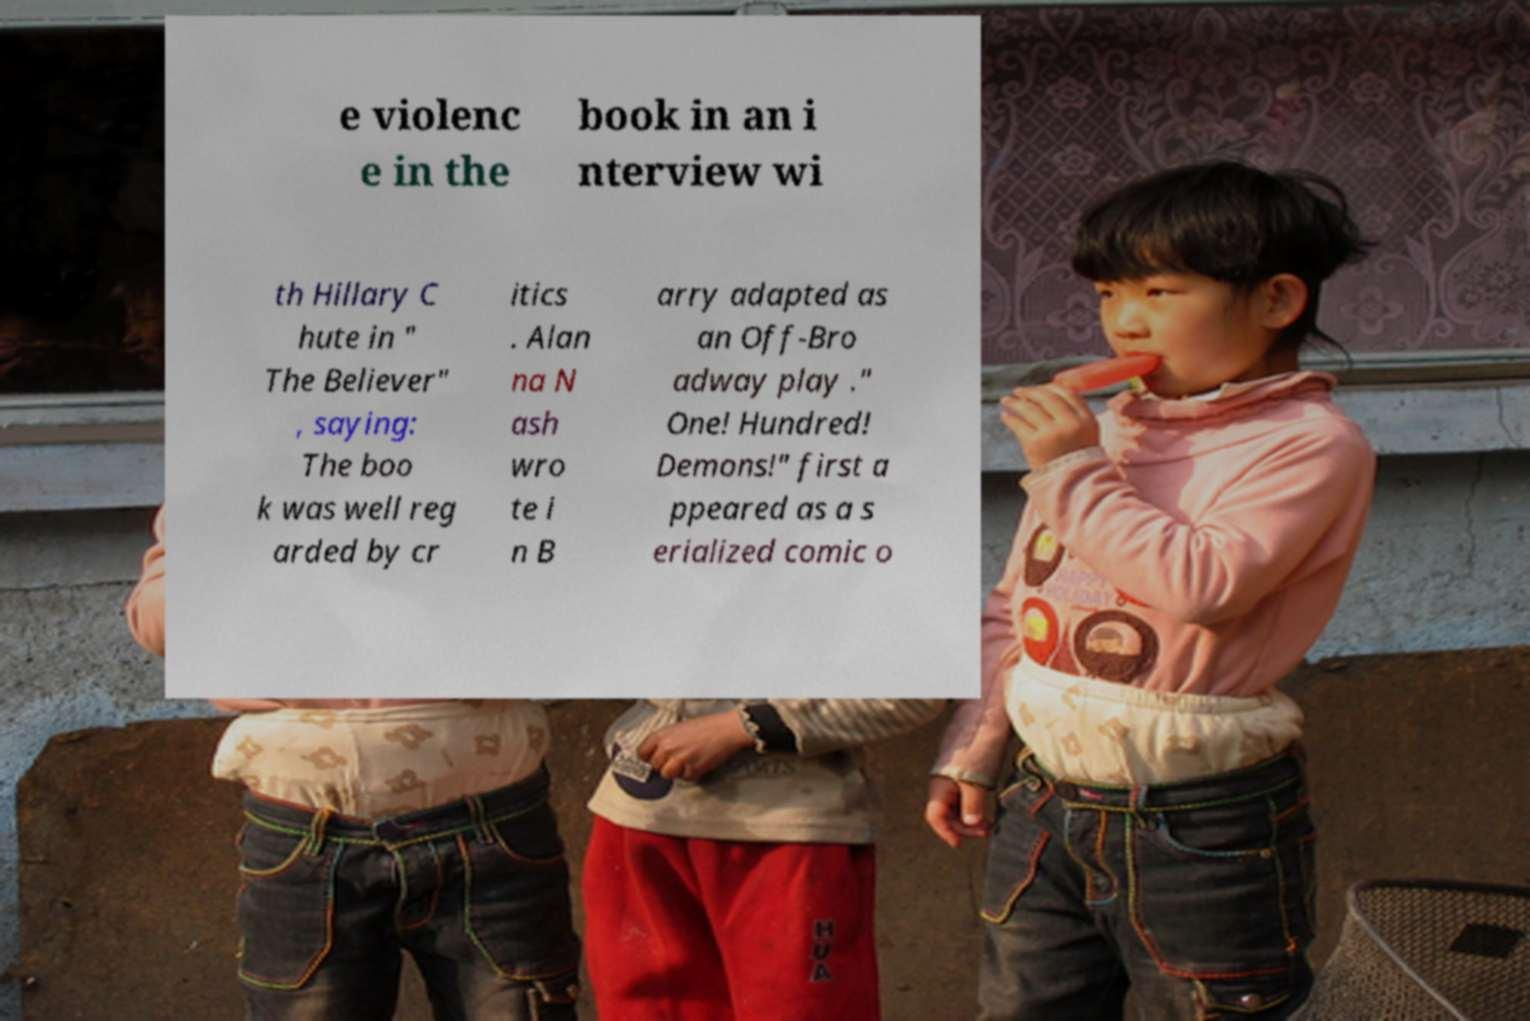Please read and relay the text visible in this image. What does it say? e violenc e in the book in an i nterview wi th Hillary C hute in " The Believer" , saying: The boo k was well reg arded by cr itics . Alan na N ash wro te i n B arry adapted as an Off-Bro adway play ." One! Hundred! Demons!" first a ppeared as a s erialized comic o 